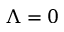<formula> <loc_0><loc_0><loc_500><loc_500>\Lambda = 0</formula> 